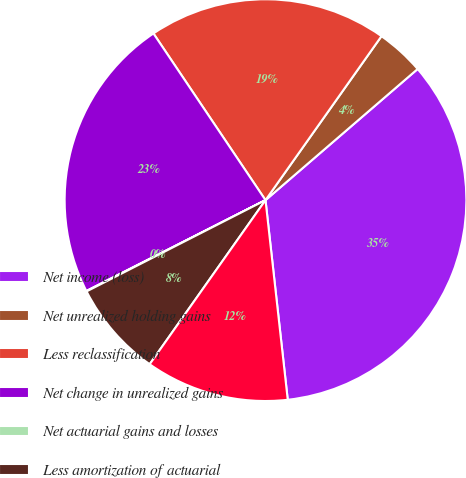Convert chart to OTSL. <chart><loc_0><loc_0><loc_500><loc_500><pie_chart><fcel>Net income (loss)<fcel>Net unrealized holding gains<fcel>Less reclassification<fcel>Net change in unrealized gains<fcel>Net actuarial gains and losses<fcel>Less amortization of actuarial<fcel>Net change from defined<nl><fcel>34.56%<fcel>3.88%<fcel>19.22%<fcel>23.05%<fcel>0.04%<fcel>7.71%<fcel>11.55%<nl></chart> 